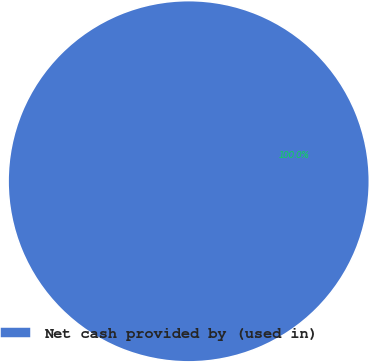Convert chart. <chart><loc_0><loc_0><loc_500><loc_500><pie_chart><fcel>Net cash provided by (used in)<nl><fcel>100.0%<nl></chart> 